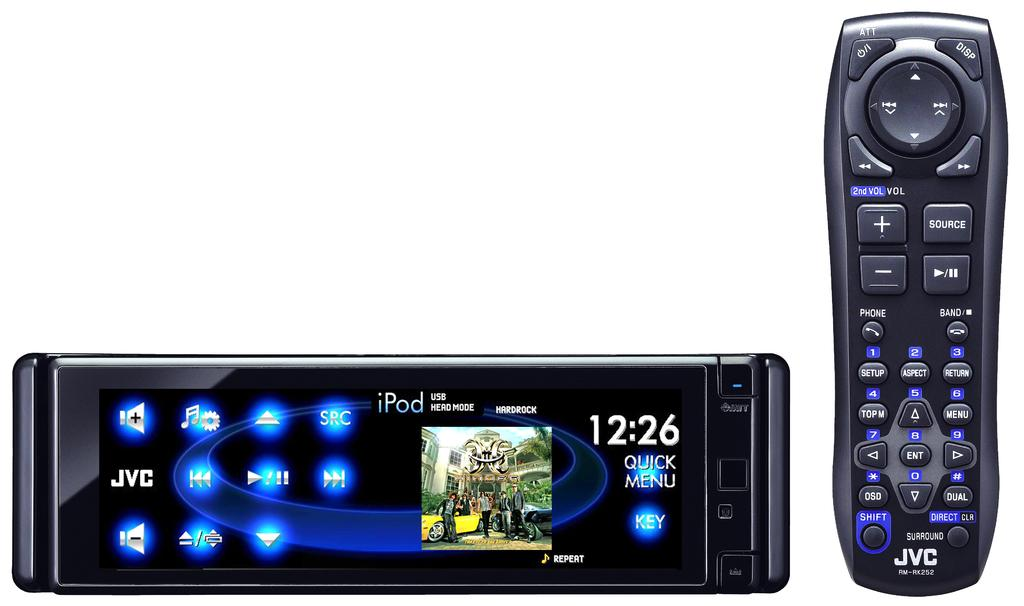<image>
Write a terse but informative summary of the picture. some kind of remote with the time of 12:26 on it 